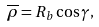Convert formula to latex. <formula><loc_0><loc_0><loc_500><loc_500>\overline { \rho } = R _ { b } \cos \gamma ,</formula> 